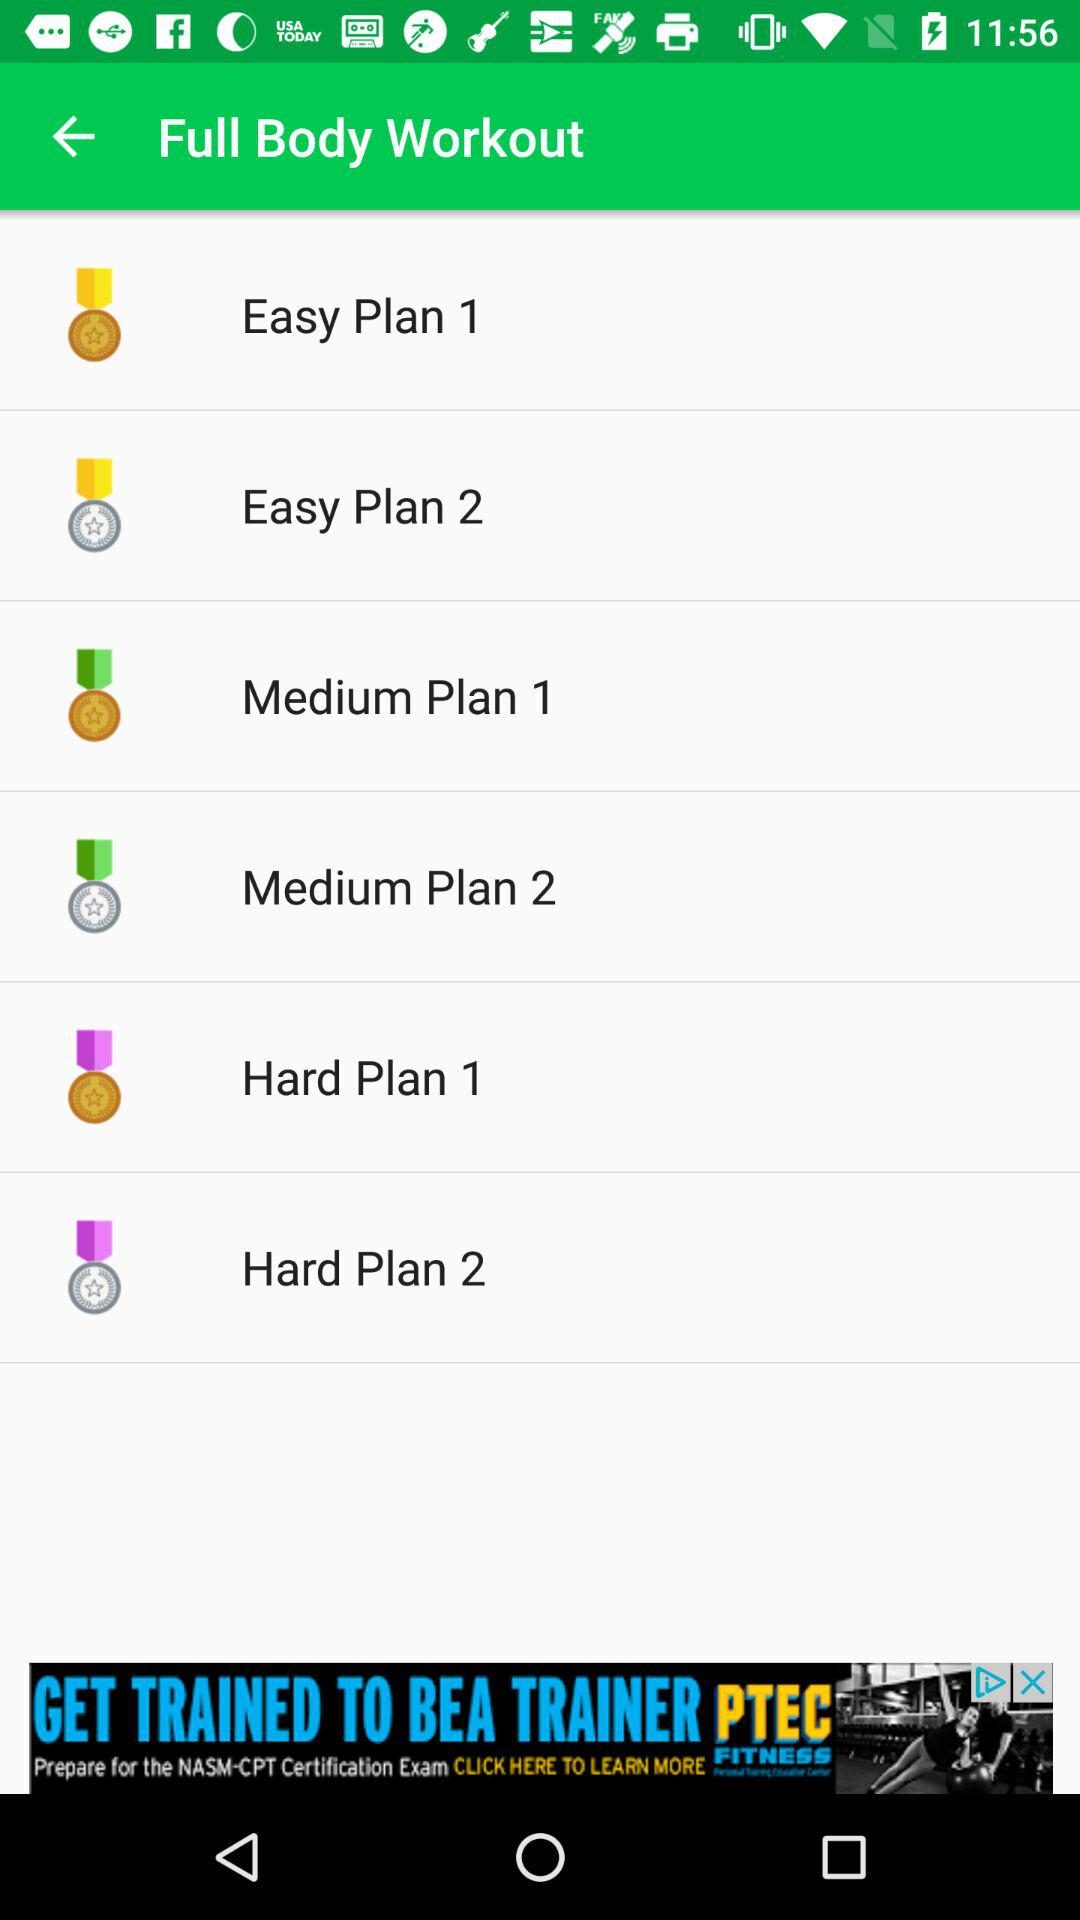What is the application name?
When the provided information is insufficient, respond with <no answer>. <no answer> 